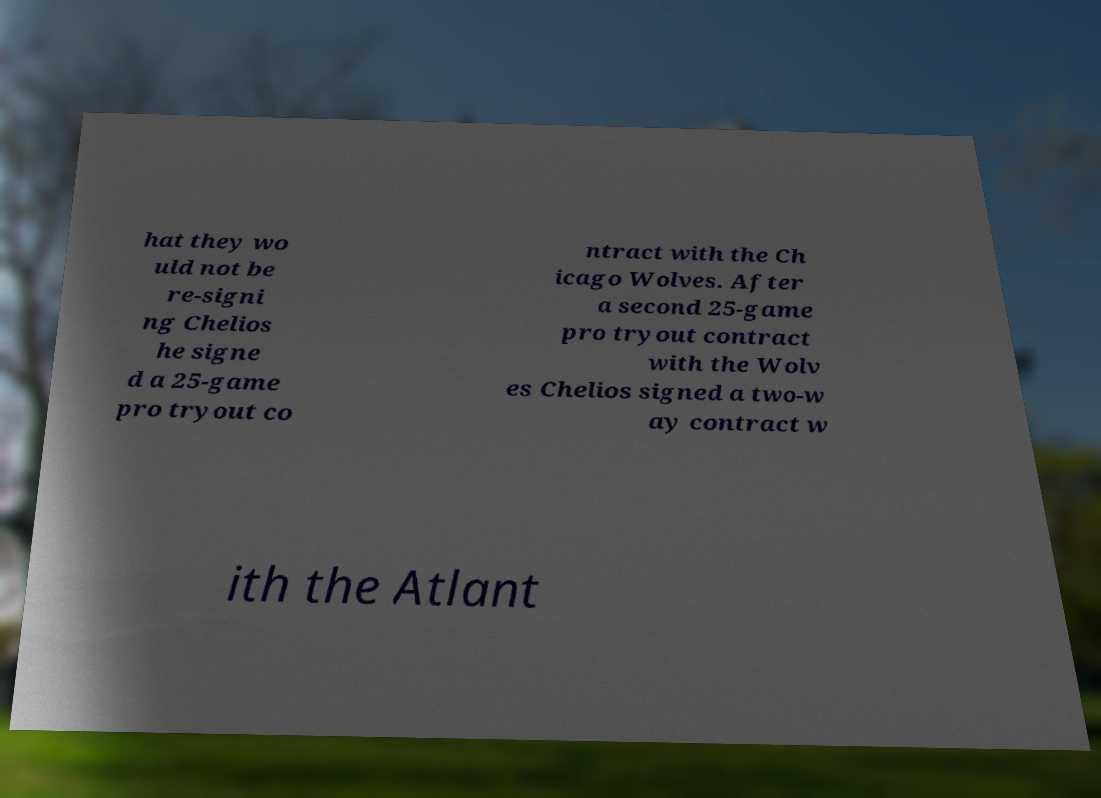What messages or text are displayed in this image? I need them in a readable, typed format. hat they wo uld not be re-signi ng Chelios he signe d a 25-game pro tryout co ntract with the Ch icago Wolves. After a second 25-game pro tryout contract with the Wolv es Chelios signed a two-w ay contract w ith the Atlant 